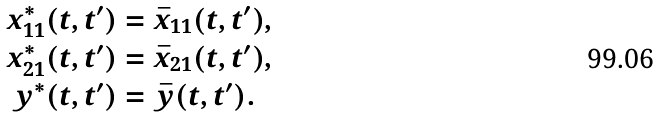<formula> <loc_0><loc_0><loc_500><loc_500>x ^ { * } _ { 1 1 } ( t , t ^ { \prime } ) & = \bar { x } _ { 1 1 } ( t , t ^ { \prime } ) , \\ x ^ { * } _ { 2 1 } ( t , t ^ { \prime } ) & = \bar { x } _ { 2 1 } ( t , t ^ { \prime } ) , \\ y ^ { * } ( t , t ^ { \prime } ) & = \bar { y } ( t , t ^ { \prime } ) .</formula> 